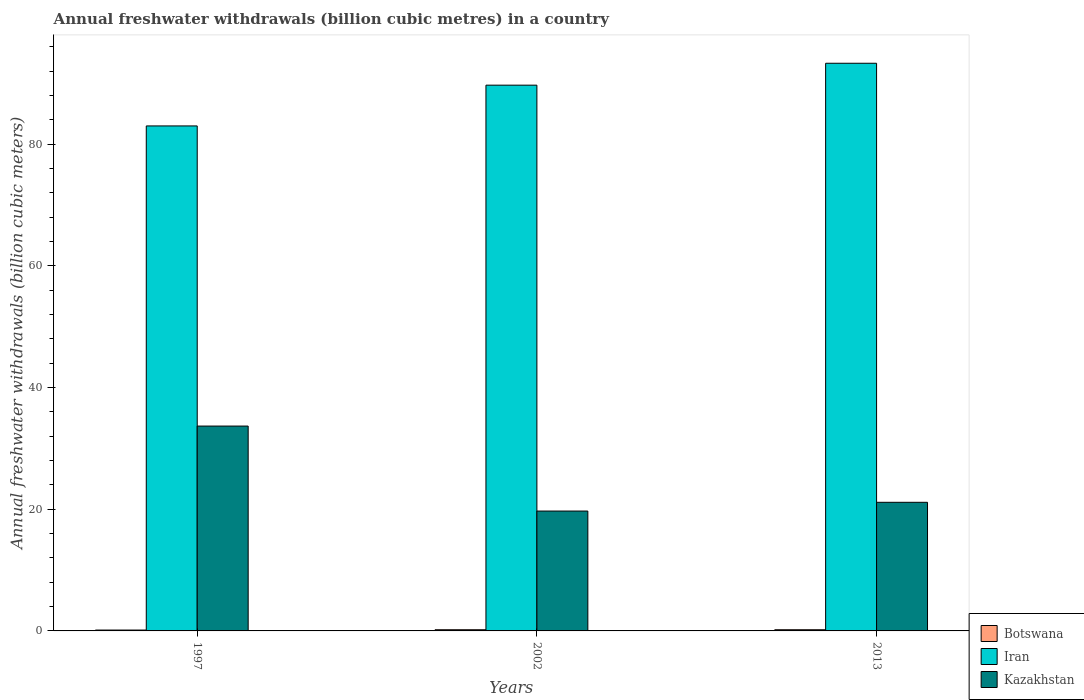How many groups of bars are there?
Offer a terse response. 3. Are the number of bars per tick equal to the number of legend labels?
Keep it short and to the point. Yes. How many bars are there on the 3rd tick from the right?
Ensure brevity in your answer.  3. What is the label of the 3rd group of bars from the left?
Ensure brevity in your answer.  2013. What is the annual freshwater withdrawals in Botswana in 1997?
Keep it short and to the point. 0.14. Across all years, what is the maximum annual freshwater withdrawals in Kazakhstan?
Provide a short and direct response. 33.67. In which year was the annual freshwater withdrawals in Kazakhstan maximum?
Make the answer very short. 1997. What is the total annual freshwater withdrawals in Iran in the graph?
Your answer should be compact. 266. What is the difference between the annual freshwater withdrawals in Iran in 2002 and that in 2013?
Make the answer very short. -3.6. What is the difference between the annual freshwater withdrawals in Botswana in 1997 and the annual freshwater withdrawals in Kazakhstan in 2002?
Ensure brevity in your answer.  -19.56. What is the average annual freshwater withdrawals in Iran per year?
Offer a very short reply. 88.67. In the year 2013, what is the difference between the annual freshwater withdrawals in Kazakhstan and annual freshwater withdrawals in Iran?
Your answer should be very brief. -72.16. What is the ratio of the annual freshwater withdrawals in Iran in 1997 to that in 2002?
Your answer should be compact. 0.93. What is the difference between the highest and the lowest annual freshwater withdrawals in Botswana?
Offer a terse response. 0.05. In how many years, is the annual freshwater withdrawals in Botswana greater than the average annual freshwater withdrawals in Botswana taken over all years?
Provide a short and direct response. 2. What does the 1st bar from the left in 1997 represents?
Provide a succinct answer. Botswana. What does the 1st bar from the right in 1997 represents?
Offer a very short reply. Kazakhstan. Is it the case that in every year, the sum of the annual freshwater withdrawals in Botswana and annual freshwater withdrawals in Kazakhstan is greater than the annual freshwater withdrawals in Iran?
Your answer should be compact. No. Are all the bars in the graph horizontal?
Your response must be concise. No. What is the difference between two consecutive major ticks on the Y-axis?
Your answer should be compact. 20. Does the graph contain any zero values?
Keep it short and to the point. No. Where does the legend appear in the graph?
Offer a terse response. Bottom right. How many legend labels are there?
Offer a terse response. 3. How are the legend labels stacked?
Ensure brevity in your answer.  Vertical. What is the title of the graph?
Provide a succinct answer. Annual freshwater withdrawals (billion cubic metres) in a country. What is the label or title of the Y-axis?
Offer a very short reply. Annual freshwater withdrawals (billion cubic meters). What is the Annual freshwater withdrawals (billion cubic meters) of Botswana in 1997?
Offer a terse response. 0.14. What is the Annual freshwater withdrawals (billion cubic meters) of Kazakhstan in 1997?
Your answer should be compact. 33.67. What is the Annual freshwater withdrawals (billion cubic meters) of Botswana in 2002?
Your response must be concise. 0.19. What is the Annual freshwater withdrawals (billion cubic meters) of Iran in 2002?
Your answer should be very brief. 89.7. What is the Annual freshwater withdrawals (billion cubic meters) of Botswana in 2013?
Offer a terse response. 0.19. What is the Annual freshwater withdrawals (billion cubic meters) of Iran in 2013?
Offer a very short reply. 93.3. What is the Annual freshwater withdrawals (billion cubic meters) of Kazakhstan in 2013?
Offer a very short reply. 21.14. Across all years, what is the maximum Annual freshwater withdrawals (billion cubic meters) of Botswana?
Your answer should be very brief. 0.19. Across all years, what is the maximum Annual freshwater withdrawals (billion cubic meters) of Iran?
Ensure brevity in your answer.  93.3. Across all years, what is the maximum Annual freshwater withdrawals (billion cubic meters) in Kazakhstan?
Make the answer very short. 33.67. Across all years, what is the minimum Annual freshwater withdrawals (billion cubic meters) of Botswana?
Make the answer very short. 0.14. Across all years, what is the minimum Annual freshwater withdrawals (billion cubic meters) of Iran?
Your answer should be very brief. 83. What is the total Annual freshwater withdrawals (billion cubic meters) in Botswana in the graph?
Offer a very short reply. 0.53. What is the total Annual freshwater withdrawals (billion cubic meters) of Iran in the graph?
Your answer should be compact. 266. What is the total Annual freshwater withdrawals (billion cubic meters) in Kazakhstan in the graph?
Offer a terse response. 74.51. What is the difference between the Annual freshwater withdrawals (billion cubic meters) of Botswana in 1997 and that in 2002?
Provide a succinct answer. -0.05. What is the difference between the Annual freshwater withdrawals (billion cubic meters) in Kazakhstan in 1997 and that in 2002?
Your answer should be very brief. 13.97. What is the difference between the Annual freshwater withdrawals (billion cubic meters) in Botswana in 1997 and that in 2013?
Your answer should be very brief. -0.05. What is the difference between the Annual freshwater withdrawals (billion cubic meters) of Iran in 1997 and that in 2013?
Your response must be concise. -10.3. What is the difference between the Annual freshwater withdrawals (billion cubic meters) in Kazakhstan in 1997 and that in 2013?
Offer a very short reply. 12.53. What is the difference between the Annual freshwater withdrawals (billion cubic meters) of Iran in 2002 and that in 2013?
Your answer should be compact. -3.6. What is the difference between the Annual freshwater withdrawals (billion cubic meters) in Kazakhstan in 2002 and that in 2013?
Provide a short and direct response. -1.44. What is the difference between the Annual freshwater withdrawals (billion cubic meters) in Botswana in 1997 and the Annual freshwater withdrawals (billion cubic meters) in Iran in 2002?
Your response must be concise. -89.56. What is the difference between the Annual freshwater withdrawals (billion cubic meters) of Botswana in 1997 and the Annual freshwater withdrawals (billion cubic meters) of Kazakhstan in 2002?
Keep it short and to the point. -19.56. What is the difference between the Annual freshwater withdrawals (billion cubic meters) in Iran in 1997 and the Annual freshwater withdrawals (billion cubic meters) in Kazakhstan in 2002?
Ensure brevity in your answer.  63.3. What is the difference between the Annual freshwater withdrawals (billion cubic meters) of Botswana in 1997 and the Annual freshwater withdrawals (billion cubic meters) of Iran in 2013?
Your response must be concise. -93.16. What is the difference between the Annual freshwater withdrawals (billion cubic meters) in Botswana in 1997 and the Annual freshwater withdrawals (billion cubic meters) in Kazakhstan in 2013?
Offer a terse response. -21. What is the difference between the Annual freshwater withdrawals (billion cubic meters) of Iran in 1997 and the Annual freshwater withdrawals (billion cubic meters) of Kazakhstan in 2013?
Make the answer very short. 61.86. What is the difference between the Annual freshwater withdrawals (billion cubic meters) in Botswana in 2002 and the Annual freshwater withdrawals (billion cubic meters) in Iran in 2013?
Make the answer very short. -93.11. What is the difference between the Annual freshwater withdrawals (billion cubic meters) in Botswana in 2002 and the Annual freshwater withdrawals (billion cubic meters) in Kazakhstan in 2013?
Your answer should be compact. -20.95. What is the difference between the Annual freshwater withdrawals (billion cubic meters) in Iran in 2002 and the Annual freshwater withdrawals (billion cubic meters) in Kazakhstan in 2013?
Ensure brevity in your answer.  68.56. What is the average Annual freshwater withdrawals (billion cubic meters) of Botswana per year?
Your response must be concise. 0.18. What is the average Annual freshwater withdrawals (billion cubic meters) of Iran per year?
Provide a succinct answer. 88.67. What is the average Annual freshwater withdrawals (billion cubic meters) in Kazakhstan per year?
Keep it short and to the point. 24.84. In the year 1997, what is the difference between the Annual freshwater withdrawals (billion cubic meters) of Botswana and Annual freshwater withdrawals (billion cubic meters) of Iran?
Provide a short and direct response. -82.86. In the year 1997, what is the difference between the Annual freshwater withdrawals (billion cubic meters) in Botswana and Annual freshwater withdrawals (billion cubic meters) in Kazakhstan?
Your response must be concise. -33.53. In the year 1997, what is the difference between the Annual freshwater withdrawals (billion cubic meters) of Iran and Annual freshwater withdrawals (billion cubic meters) of Kazakhstan?
Your response must be concise. 49.33. In the year 2002, what is the difference between the Annual freshwater withdrawals (billion cubic meters) of Botswana and Annual freshwater withdrawals (billion cubic meters) of Iran?
Provide a succinct answer. -89.51. In the year 2002, what is the difference between the Annual freshwater withdrawals (billion cubic meters) of Botswana and Annual freshwater withdrawals (billion cubic meters) of Kazakhstan?
Make the answer very short. -19.51. In the year 2002, what is the difference between the Annual freshwater withdrawals (billion cubic meters) in Iran and Annual freshwater withdrawals (billion cubic meters) in Kazakhstan?
Provide a short and direct response. 70. In the year 2013, what is the difference between the Annual freshwater withdrawals (billion cubic meters) of Botswana and Annual freshwater withdrawals (billion cubic meters) of Iran?
Offer a very short reply. -93.11. In the year 2013, what is the difference between the Annual freshwater withdrawals (billion cubic meters) of Botswana and Annual freshwater withdrawals (billion cubic meters) of Kazakhstan?
Give a very brief answer. -20.95. In the year 2013, what is the difference between the Annual freshwater withdrawals (billion cubic meters) in Iran and Annual freshwater withdrawals (billion cubic meters) in Kazakhstan?
Your answer should be compact. 72.16. What is the ratio of the Annual freshwater withdrawals (billion cubic meters) of Botswana in 1997 to that in 2002?
Provide a short and direct response. 0.74. What is the ratio of the Annual freshwater withdrawals (billion cubic meters) in Iran in 1997 to that in 2002?
Offer a terse response. 0.93. What is the ratio of the Annual freshwater withdrawals (billion cubic meters) in Kazakhstan in 1997 to that in 2002?
Offer a very short reply. 1.71. What is the ratio of the Annual freshwater withdrawals (billion cubic meters) of Botswana in 1997 to that in 2013?
Make the answer very short. 0.74. What is the ratio of the Annual freshwater withdrawals (billion cubic meters) of Iran in 1997 to that in 2013?
Keep it short and to the point. 0.89. What is the ratio of the Annual freshwater withdrawals (billion cubic meters) of Kazakhstan in 1997 to that in 2013?
Keep it short and to the point. 1.59. What is the ratio of the Annual freshwater withdrawals (billion cubic meters) of Iran in 2002 to that in 2013?
Offer a terse response. 0.96. What is the ratio of the Annual freshwater withdrawals (billion cubic meters) of Kazakhstan in 2002 to that in 2013?
Your response must be concise. 0.93. What is the difference between the highest and the second highest Annual freshwater withdrawals (billion cubic meters) of Botswana?
Keep it short and to the point. 0. What is the difference between the highest and the second highest Annual freshwater withdrawals (billion cubic meters) of Iran?
Offer a terse response. 3.6. What is the difference between the highest and the second highest Annual freshwater withdrawals (billion cubic meters) in Kazakhstan?
Offer a terse response. 12.53. What is the difference between the highest and the lowest Annual freshwater withdrawals (billion cubic meters) of Botswana?
Ensure brevity in your answer.  0.05. What is the difference between the highest and the lowest Annual freshwater withdrawals (billion cubic meters) in Iran?
Provide a short and direct response. 10.3. What is the difference between the highest and the lowest Annual freshwater withdrawals (billion cubic meters) of Kazakhstan?
Keep it short and to the point. 13.97. 